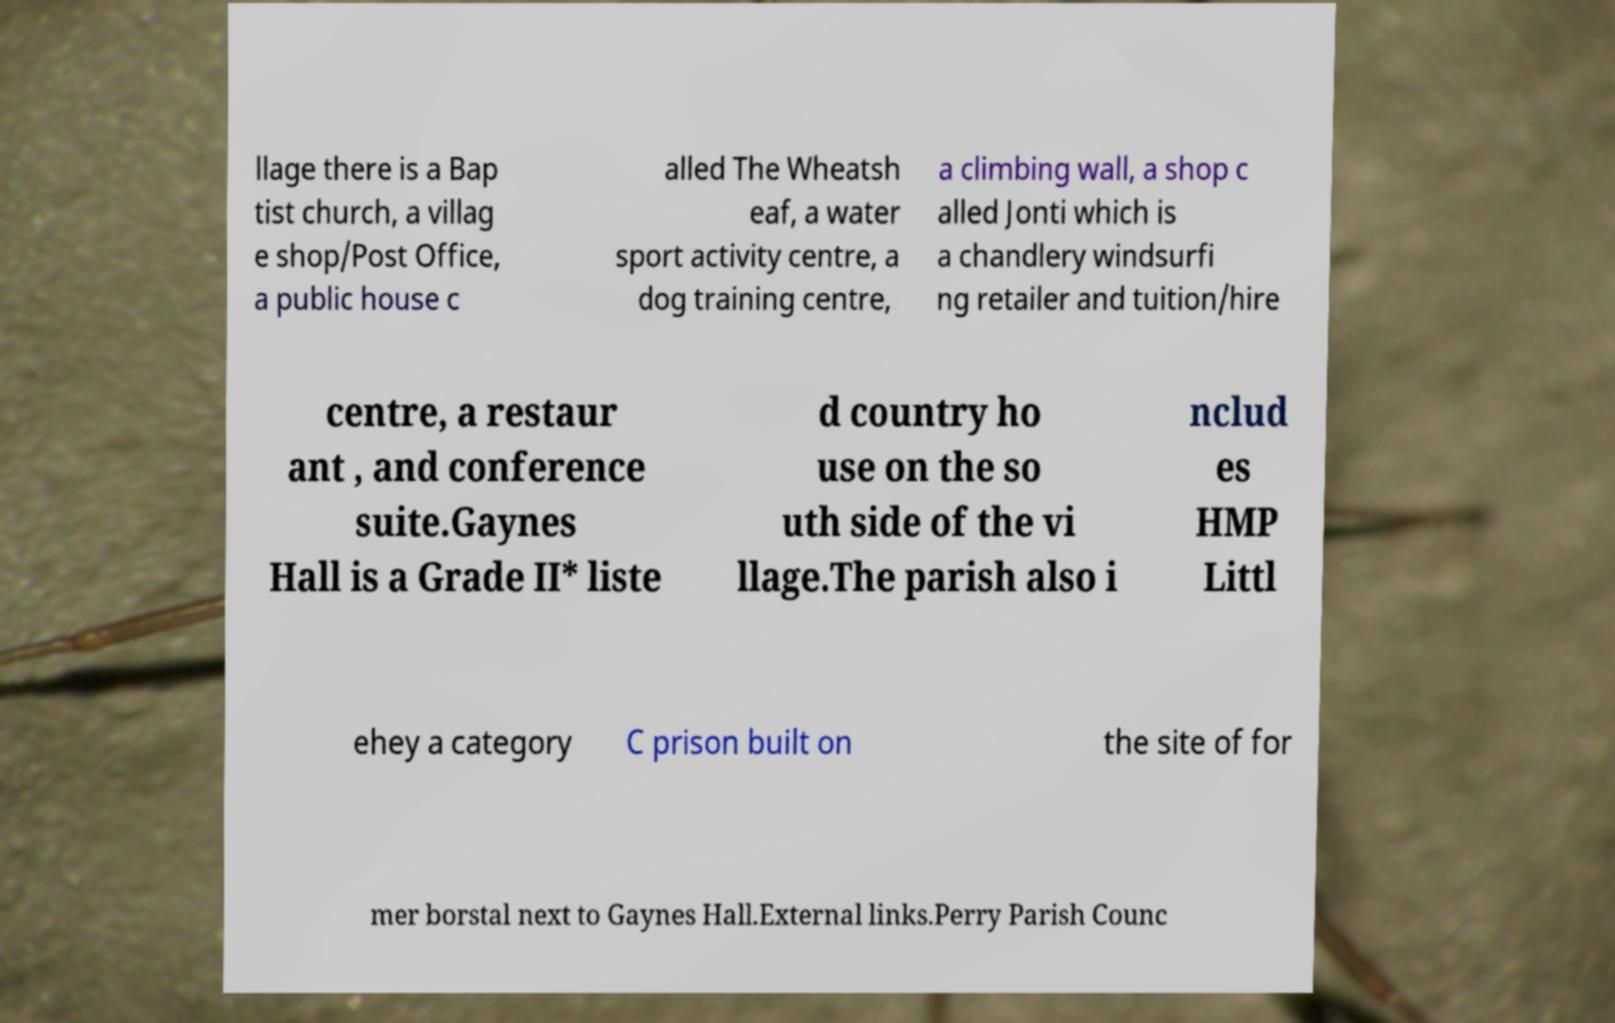Please identify and transcribe the text found in this image. llage there is a Bap tist church, a villag e shop/Post Office, a public house c alled The Wheatsh eaf, a water sport activity centre, a dog training centre, a climbing wall, a shop c alled Jonti which is a chandlery windsurfi ng retailer and tuition/hire centre, a restaur ant , and conference suite.Gaynes Hall is a Grade II* liste d country ho use on the so uth side of the vi llage.The parish also i nclud es HMP Littl ehey a category C prison built on the site of for mer borstal next to Gaynes Hall.External links.Perry Parish Counc 